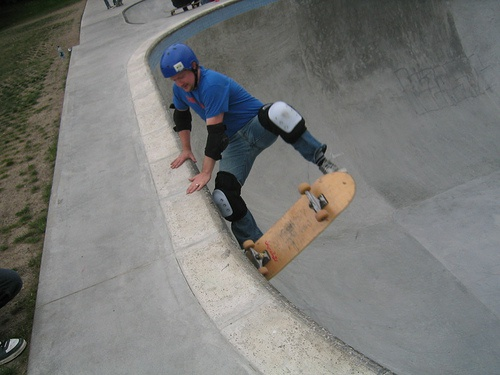Describe the objects in this image and their specific colors. I can see people in black, navy, gray, and darkblue tones, skateboard in black, tan, and gray tones, and bottle in black, gray, and blue tones in this image. 